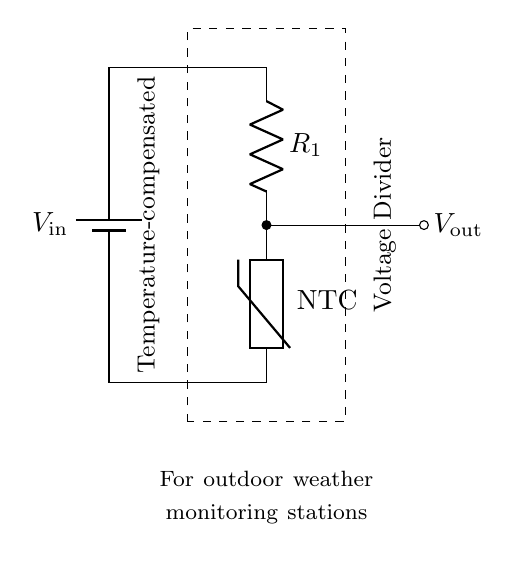What type of resistor is used in this circuit? The diagram indicates an NTC thermistor is connected, which is a type of resistor that decreases in resistance as temperature increases.
Answer: NTC thermistor What is the function of the thermistor in this circuit? The thermistor compensates for temperature variations, providing stable voltage output despite temperature fluctuations, which is crucial for accurate weather monitoring.
Answer: Temperature compensation What is the output voltage labeled in the circuit? The output voltage, labeled as V_out, is taken from the connection point between R_1 and the thermistor, indicating the point where the divided voltage is measured.
Answer: V_out What components are used in the voltage divider? The circuit comprises a battery (V_in), a resistor (R_1), and a thermistor, which are arranged to form the voltage divider where R_1 and the thermistor divide the input voltage.
Answer: Battery, resistor, thermistor How does the temperature affect the output voltage? As the temperature increases, the resistance of the NTC thermistor decreases. This change in resistance affects the division of the input voltage, leading to variations in the output voltage (V_out).
Answer: Output voltage varies with temperature 